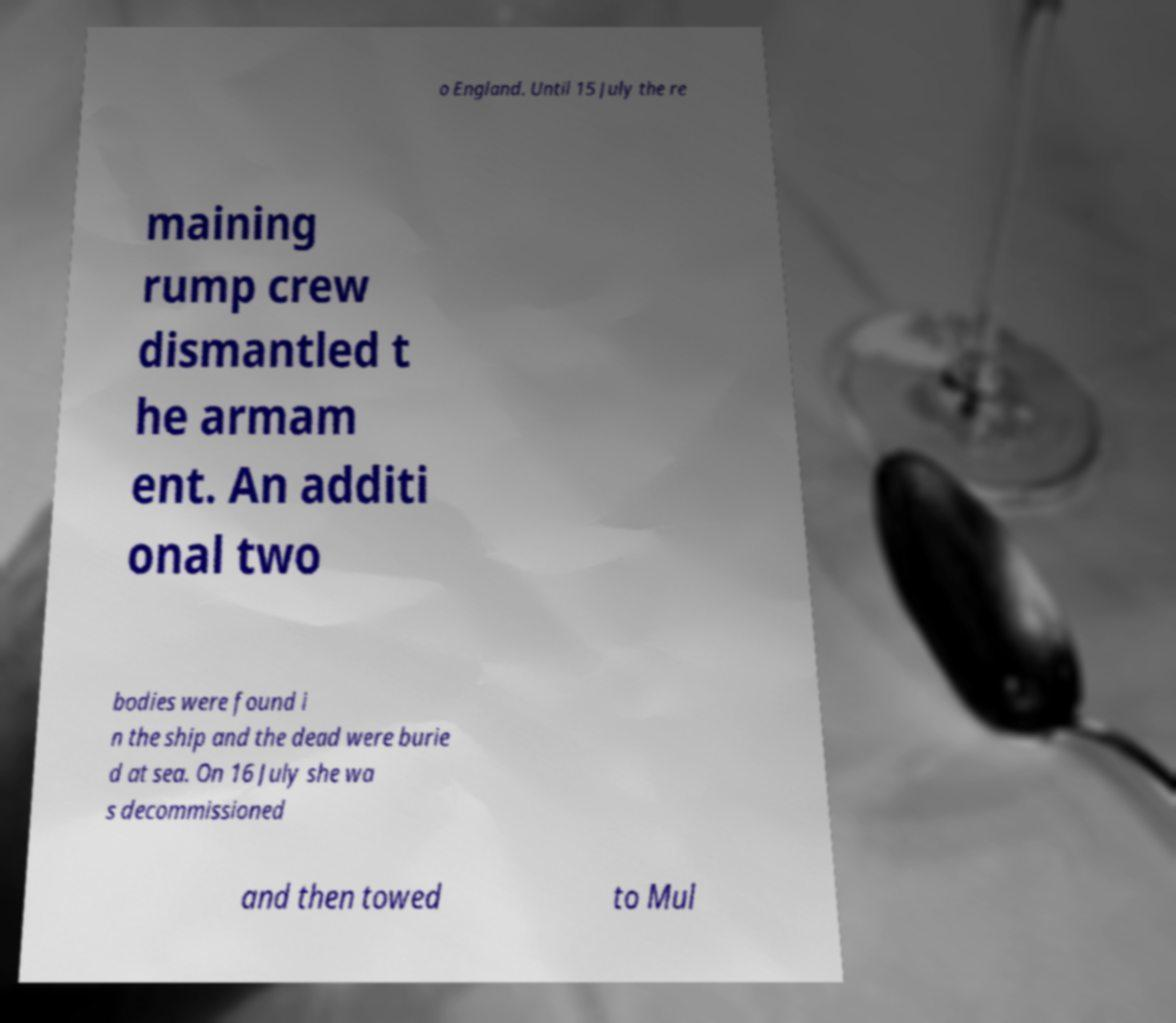For documentation purposes, I need the text within this image transcribed. Could you provide that? o England. Until 15 July the re maining rump crew dismantled t he armam ent. An additi onal two bodies were found i n the ship and the dead were burie d at sea. On 16 July she wa s decommissioned and then towed to Mul 